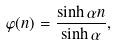Convert formula to latex. <formula><loc_0><loc_0><loc_500><loc_500>\varphi ( n ) = \frac { \sinh \alpha n } { \sinh \alpha } ,</formula> 